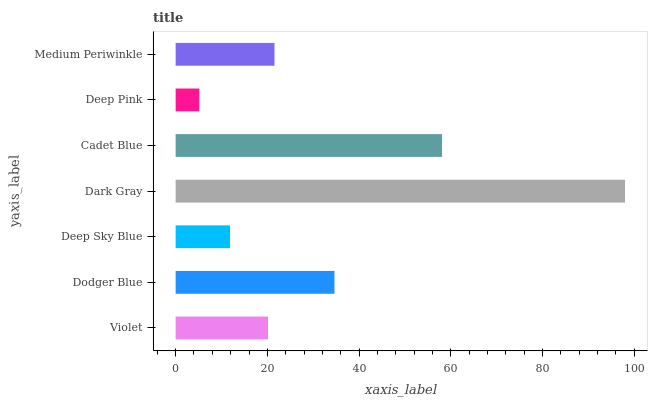Is Deep Pink the minimum?
Answer yes or no. Yes. Is Dark Gray the maximum?
Answer yes or no. Yes. Is Dodger Blue the minimum?
Answer yes or no. No. Is Dodger Blue the maximum?
Answer yes or no. No. Is Dodger Blue greater than Violet?
Answer yes or no. Yes. Is Violet less than Dodger Blue?
Answer yes or no. Yes. Is Violet greater than Dodger Blue?
Answer yes or no. No. Is Dodger Blue less than Violet?
Answer yes or no. No. Is Medium Periwinkle the high median?
Answer yes or no. Yes. Is Medium Periwinkle the low median?
Answer yes or no. Yes. Is Dark Gray the high median?
Answer yes or no. No. Is Deep Pink the low median?
Answer yes or no. No. 